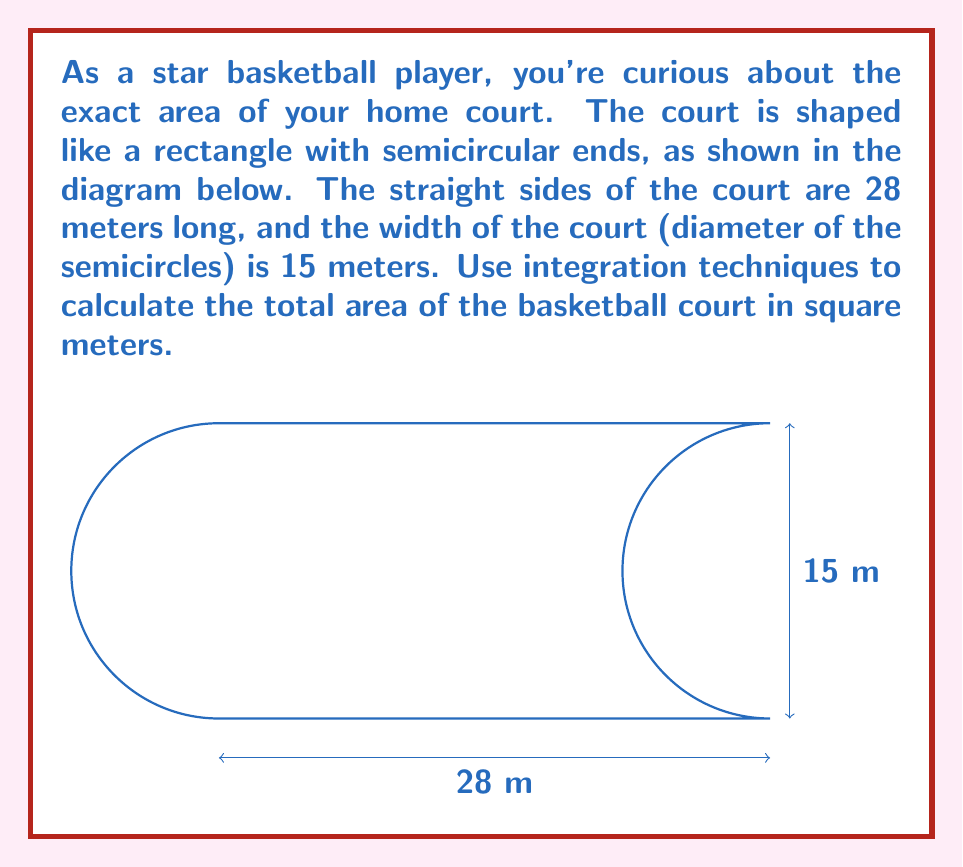Teach me how to tackle this problem. Let's approach this step-by-step:

1) The court can be divided into three parts: a rectangle in the middle and two semicircles at the ends.

2) For the rectangular part:
   Area = length × width
   $A_{rectangle} = 28 \times 15 = 420$ m²

3) For each semicircle:
   Radius = width/2 = 15/2 = 7.5 m
   Area of a circle = $\pi r^2$
   Area of a semicircle = $\frac{1}{2} \pi r^2$

4) We can use integration to calculate the area of the semicircle:
   $$A_{semicircle} = \int_{-r}^r \sqrt{r^2 - x^2} dx$$
   where $r = 7.5$

5) Solving this integral:
   $$\begin{align}
   A_{semicircle} &= \int_{-7.5}^{7.5} \sqrt{7.5^2 - x^2} dx \\
   &= \left.\frac{x}{2}\sqrt{7.5^2 - x^2} + \frac{7.5^2}{2}\arcsin(\frac{x}{7.5})\right|_{-7.5}^{7.5} \\
   &= \left[0 + \frac{7.5^2}{2}(\frac{\pi}{2})\right] - \left[0 + \frac{7.5^2}{2}(-\frac{\pi}{2})\right] \\
   &= \frac{7.5^2\pi}{2} = \frac{1125\pi}{8} \approx 44.18 \text{ m²}
   \end{align}$$

6) The total area is:
   $A_{total} = A_{rectangle} + 2A_{semicircle}$
   $= 420 + 2(\frac{1125\pi}{8})$
   $= 420 + \frac{1125\pi}{4}$
   $\approx 508.36 \text{ m²}$
Answer: $420 + \frac{1125\pi}{4}$ m² (≈ 508.36 m²) 